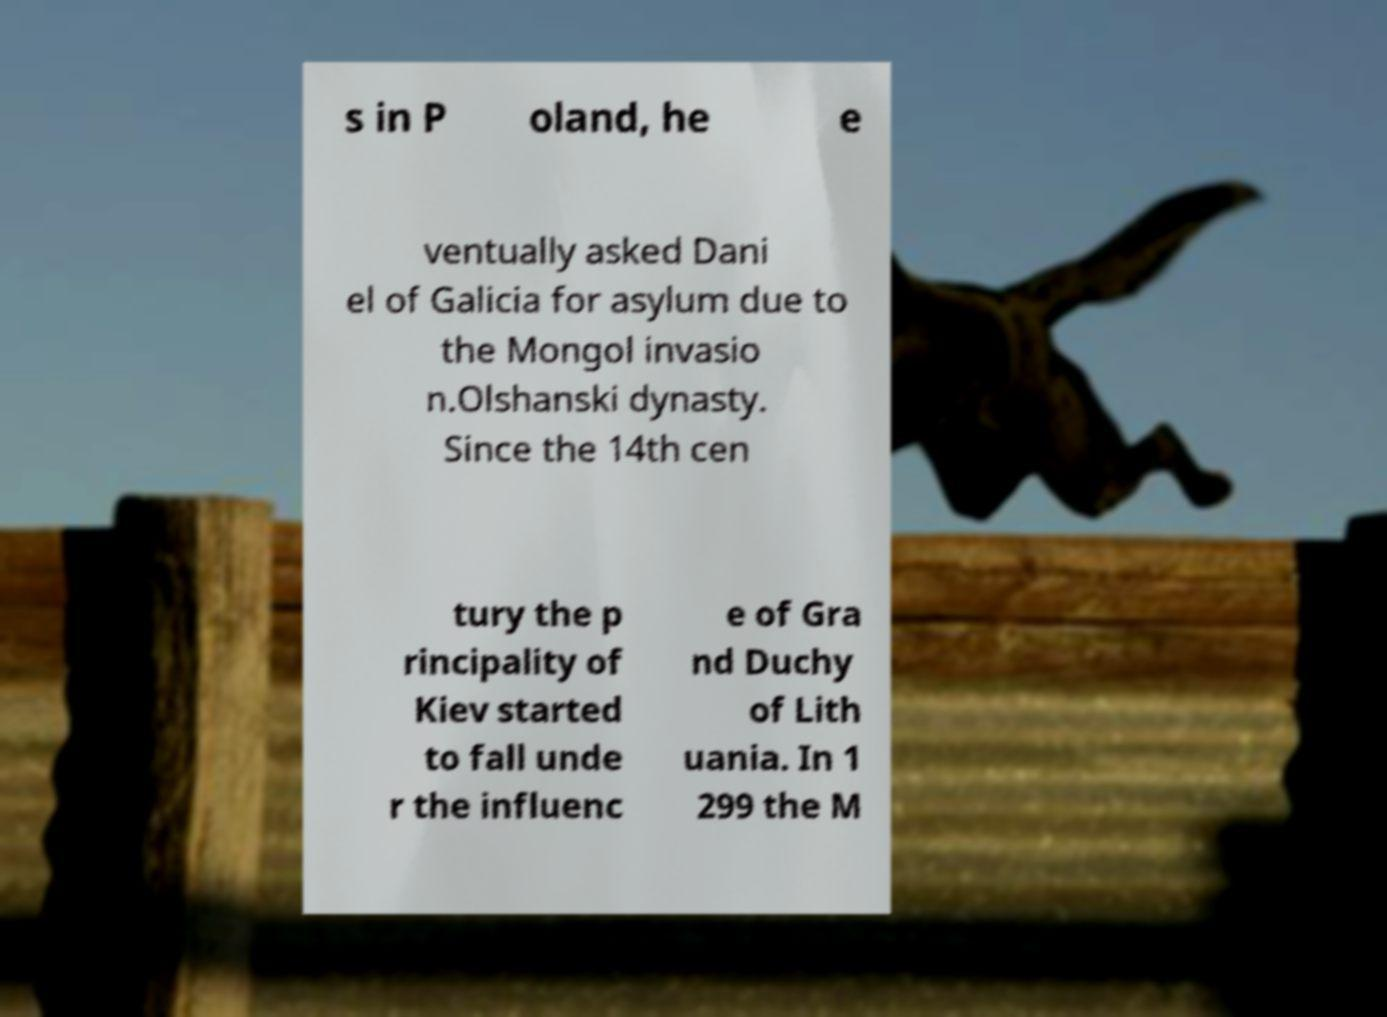There's text embedded in this image that I need extracted. Can you transcribe it verbatim? s in P oland, he e ventually asked Dani el of Galicia for asylum due to the Mongol invasio n.Olshanski dynasty. Since the 14th cen tury the p rincipality of Kiev started to fall unde r the influenc e of Gra nd Duchy of Lith uania. In 1 299 the M 